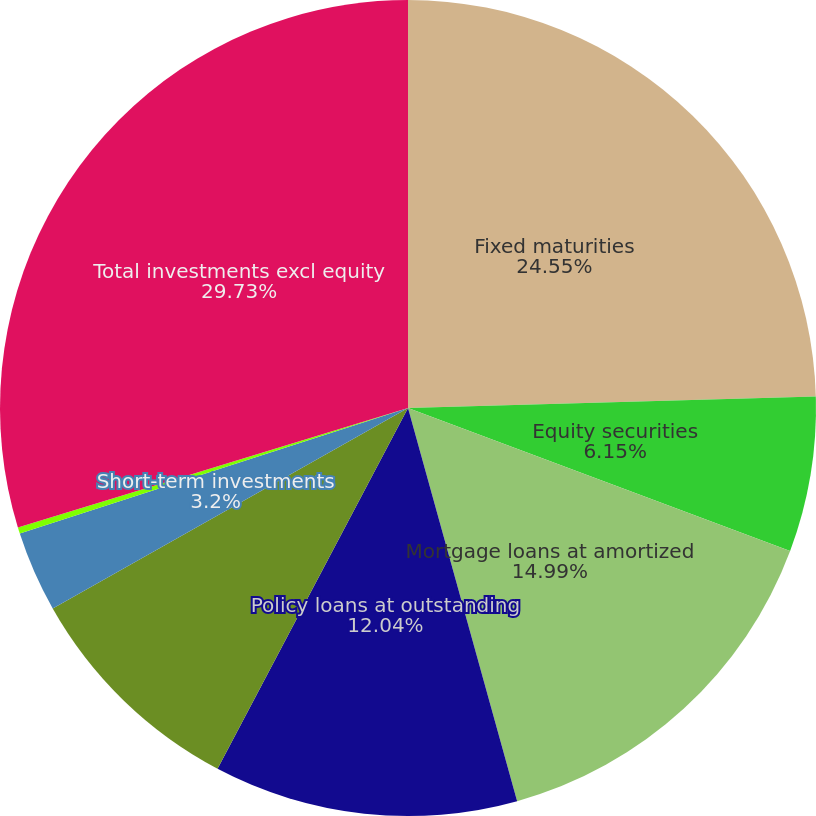Convert chart. <chart><loc_0><loc_0><loc_500><loc_500><pie_chart><fcel>Fixed maturities<fcel>Equity securities<fcel>Mortgage loans at amortized<fcel>Policy loans at outstanding<fcel>Limited partnerships and other<fcel>Short-term investments<fcel>Other investments 3<fcel>Total investments excl equity<nl><fcel>24.55%<fcel>6.15%<fcel>14.99%<fcel>12.04%<fcel>9.09%<fcel>3.2%<fcel>0.25%<fcel>29.73%<nl></chart> 